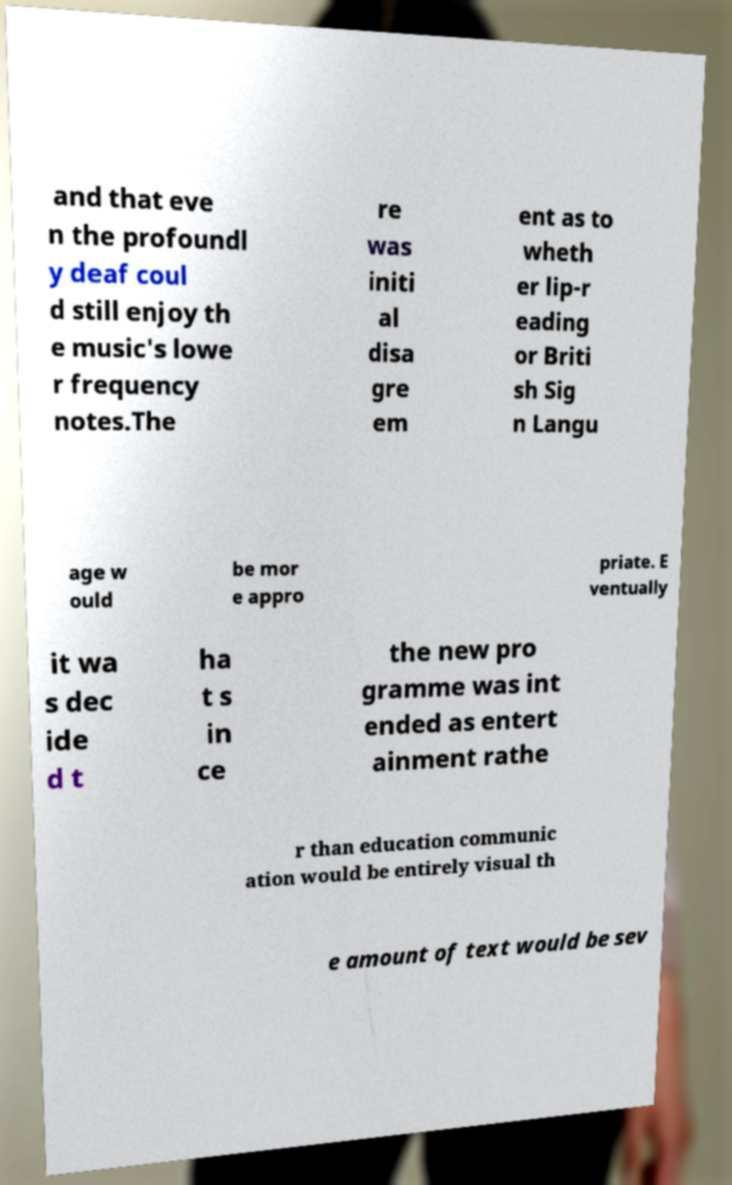I need the written content from this picture converted into text. Can you do that? and that eve n the profoundl y deaf coul d still enjoy th e music's lowe r frequency notes.The re was initi al disa gre em ent as to wheth er lip-r eading or Briti sh Sig n Langu age w ould be mor e appro priate. E ventually it wa s dec ide d t ha t s in ce the new pro gramme was int ended as entert ainment rathe r than education communic ation would be entirely visual th e amount of text would be sev 